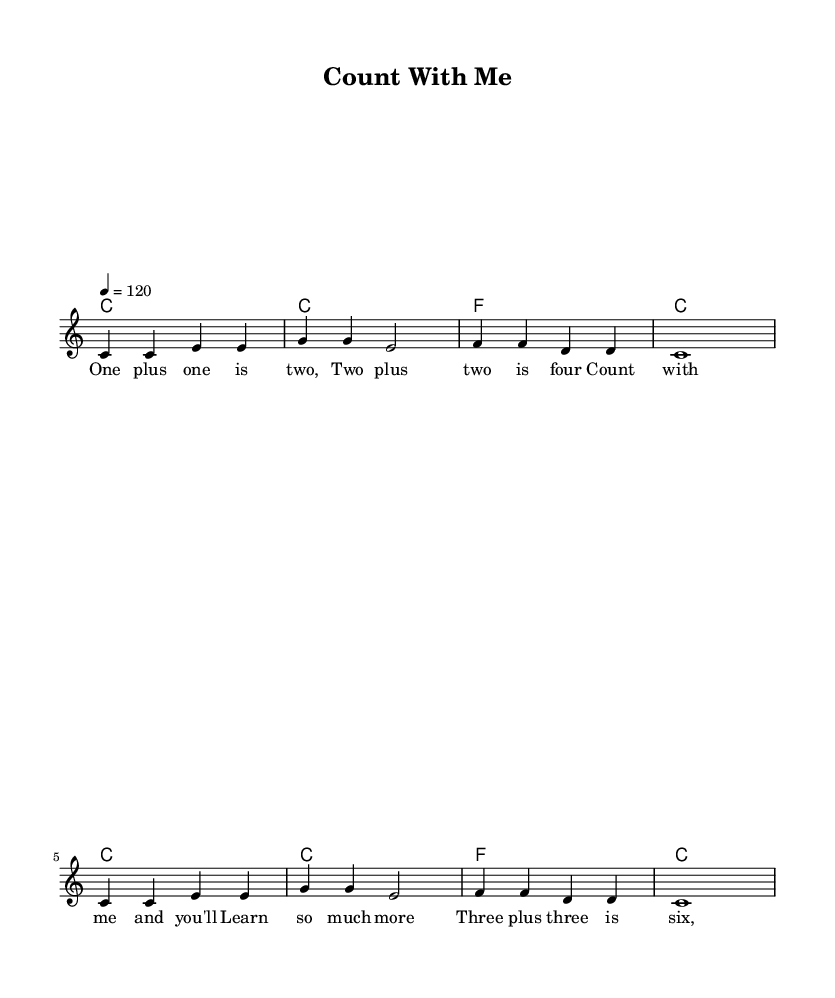What is the key signature of this music? The key signature is indicated at the beginning of the staff. It shows C major, which has no sharps or flats.
Answer: C major What is the time signature of this music? The time signature is found in the time signature marking at the beginning of the piece, which shows that there are 4 beats in each measure and a quarter note gets one beat. Thus, it is 4/4.
Answer: 4/4 What is the tempo marking of this music? The tempo marking is expressed as a number with a "bpm" (beats per minute) value. In this case, it states "4 = 120", indicating the tempo should be played at 120 beats per minute.
Answer: 120 How many measures are there in the melody? By counting the individual segments of music in the provided melody section, there are a total of 8 measures since each segment is separated by a vertical line (bar line).
Answer: 8 What is the primary theme of the lyrics? The lyrics focus on basic addition concepts, expressing simple math facts like one plus one equals two. The repeated structure suggests a learning theme. Therefore, the primary theme is basic math.
Answer: Basic math How many chords are used throughout the piece? By counting the distinct chord segments presented in the harmonies section, there are four unique chords: C, F, and repeating instances of these chords across the musical phrases.
Answer: 2 What type of music is this piece categorized as? Given the characteristics such as a catchy tune, educational aspect, and relatable lyrics, this piece fits into the Pop genre, which is known for being catchy and accessible to a wide audience.
Answer: Pop 